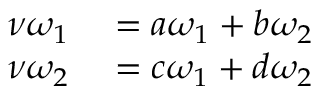<formula> <loc_0><loc_0><loc_500><loc_500>\begin{array} { r l } { \nu \omega _ { 1 } } & = a \omega _ { 1 } + b \omega _ { 2 } } \\ { \nu \omega _ { 2 } } & = c \omega _ { 1 } + d \omega _ { 2 } } \end{array}</formula> 